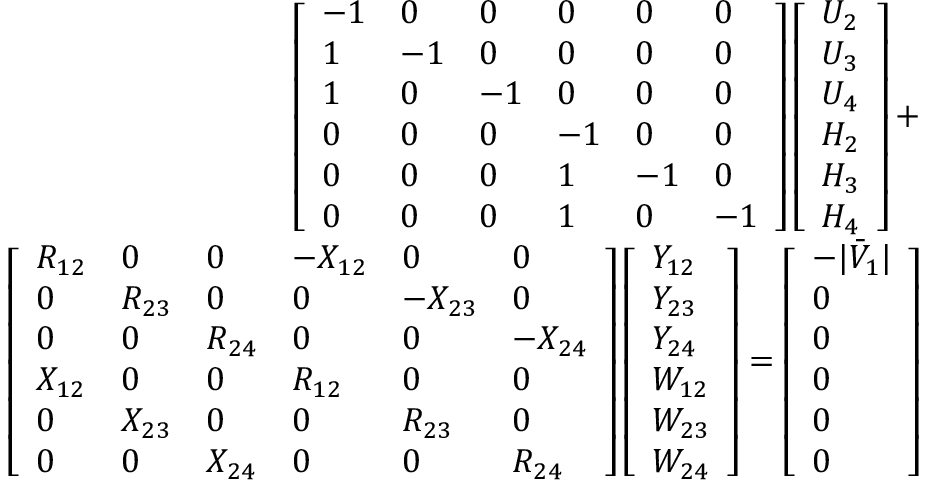Convert formula to latex. <formula><loc_0><loc_0><loc_500><loc_500>\begin{array} { r } { \left [ \begin{array} { l l l l l l } { - 1 } & { 0 } & { 0 } & { 0 } & { 0 } & { 0 } \\ { 1 } & { - 1 } & { 0 } & { 0 } & { 0 } & { 0 } \\ { 1 } & { 0 } & { - 1 } & { 0 } & { 0 } & { 0 } \\ { 0 } & { 0 } & { 0 } & { - 1 } & { 0 } & { 0 } \\ { 0 } & { 0 } & { 0 } & { 1 } & { - 1 } & { 0 } \\ { 0 } & { 0 } & { 0 } & { 1 } & { 0 } & { - 1 } \end{array} \right ] \left [ \begin{array} { l } { U _ { 2 } } \\ { U _ { 3 } } \\ { U _ { 4 } } \\ { H _ { 2 } } \\ { H _ { 3 } } \\ { H _ { 4 } } \end{array} \right ] + } \\ { \left [ \begin{array} { l l l l l l } { R _ { 1 2 } } & { 0 } & { 0 } & { - X _ { 1 2 } } & { 0 } & { 0 } \\ { 0 } & { R _ { 2 3 } } & { 0 } & { 0 } & { - X _ { 2 3 } } & { 0 } \\ { 0 } & { 0 } & { R _ { 2 4 } } & { 0 } & { 0 } & { - X _ { 2 4 } } \\ { X _ { 1 2 } } & { 0 } & { 0 } & { R _ { 1 2 } } & { 0 } & { 0 } \\ { 0 } & { X _ { 2 3 } } & { 0 } & { 0 } & { R _ { 2 3 } } & { 0 } \\ { 0 } & { 0 } & { X _ { 2 4 } } & { 0 } & { 0 } & { R _ { 2 4 } } \end{array} \right ] \left [ \begin{array} { l } { Y _ { 1 2 } } \\ { Y _ { 2 3 } } \\ { Y _ { 2 4 } } \\ { W _ { 1 2 } } \\ { W _ { 2 3 } } \\ { W _ { 2 4 } } \end{array} \right ] = \left [ \begin{array} { l } { - | \bar { V } _ { 1 } | } \\ { 0 } \\ { 0 } \\ { 0 } \\ { 0 } \\ { 0 } \end{array} \right ] } \end{array}</formula> 